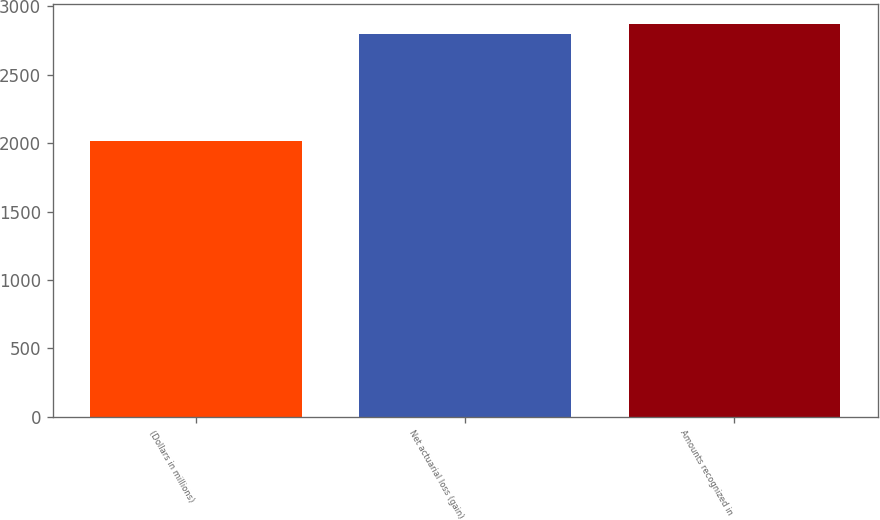<chart> <loc_0><loc_0><loc_500><loc_500><bar_chart><fcel>(Dollars in millions)<fcel>Net actuarial loss (gain)<fcel>Amounts recognized in<nl><fcel>2013<fcel>2794<fcel>2872.1<nl></chart> 